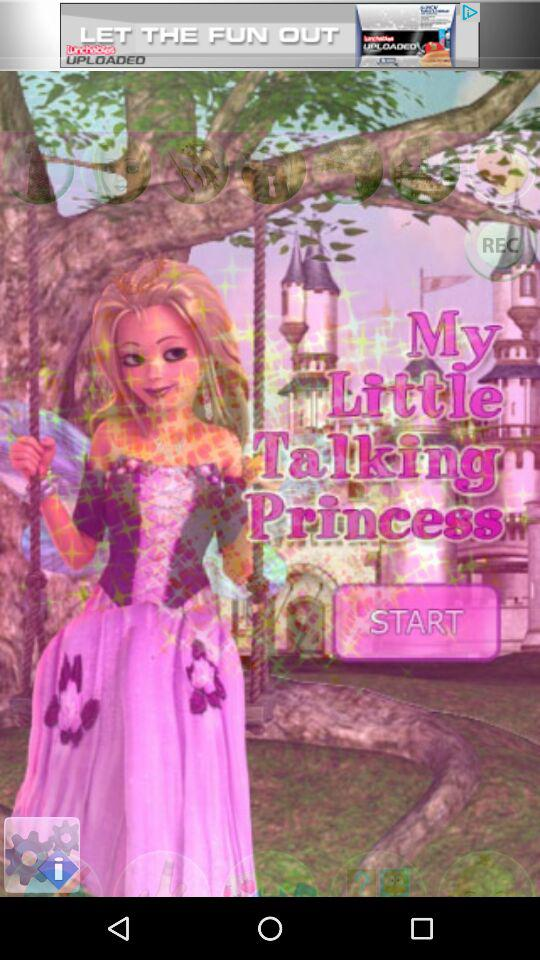What is the name of the application? The name of the application is "My Little Talking Princess". 